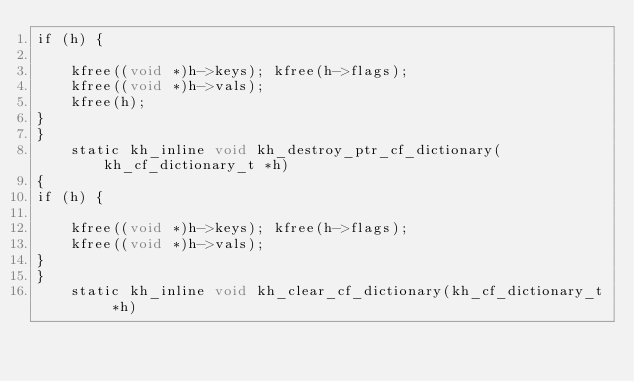<code> <loc_0><loc_0><loc_500><loc_500><_ObjectiveC_>if (h) {
    
    kfree((void *)h->keys); kfree(h->flags);                    
    kfree((void *)h->vals);                                     
    kfree(h);                                                   
}                                                               
}                                                                   
    static kh_inline void kh_destroy_ptr_cf_dictionary(kh_cf_dictionary_t *h)                   
{                                                                   
if (h) {

    kfree((void *)h->keys); kfree(h->flags);                    
    kfree((void *)h->vals);                                     
}                                                               
}                                                                   
    static kh_inline void kh_clear_cf_dictionary(kh_cf_dictionary_t *h)                     </code> 